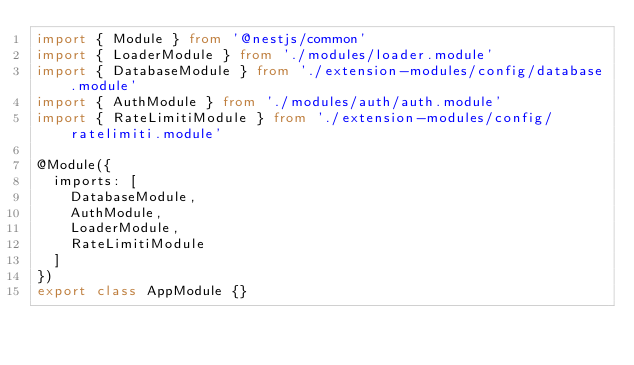<code> <loc_0><loc_0><loc_500><loc_500><_TypeScript_>import { Module } from '@nestjs/common'
import { LoaderModule } from './modules/loader.module'
import { DatabaseModule } from './extension-modules/config/database.module'
import { AuthModule } from './modules/auth/auth.module'
import { RateLimitiModule } from './extension-modules/config/ratelimiti.module'

@Module({
  imports: [
    DatabaseModule,
    AuthModule,
    LoaderModule,
    RateLimitiModule
  ]
})
export class AppModule {}
</code> 